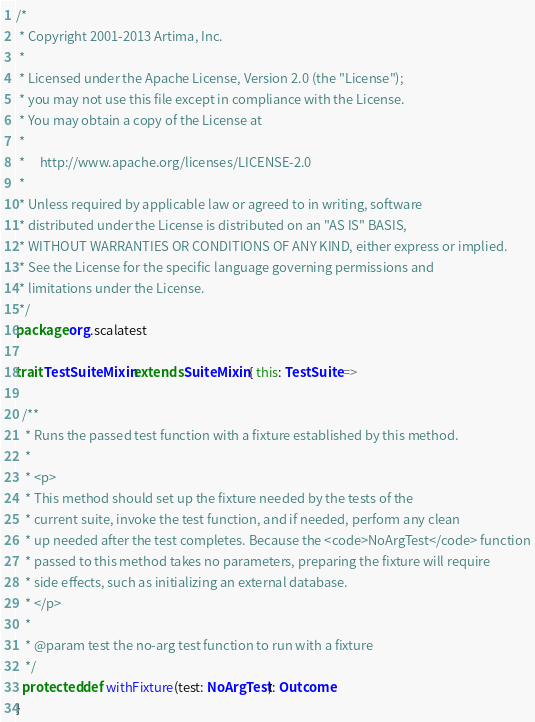<code> <loc_0><loc_0><loc_500><loc_500><_Scala_>/*
 * Copyright 2001-2013 Artima, Inc.
 *
 * Licensed under the Apache License, Version 2.0 (the "License");
 * you may not use this file except in compliance with the License.
 * You may obtain a copy of the License at
 *
 *     http://www.apache.org/licenses/LICENSE-2.0
 *
 * Unless required by applicable law or agreed to in writing, software
 * distributed under the License is distributed on an "AS IS" BASIS,
 * WITHOUT WARRANTIES OR CONDITIONS OF ANY KIND, either express or implied.
 * See the License for the specific language governing permissions and
 * limitations under the License.
 */
package org.scalatest

trait TestSuiteMixin extends SuiteMixin { this: TestSuite =>

  /**
   * Runs the passed test function with a fixture established by this method.
   *
   * <p>
   * This method should set up the fixture needed by the tests of the
   * current suite, invoke the test function, and if needed, perform any clean
   * up needed after the test completes. Because the <code>NoArgTest</code> function
   * passed to this method takes no parameters, preparing the fixture will require
   * side effects, such as initializing an external database.
   * </p>
   *
   * @param test the no-arg test function to run with a fixture
   */
  protected def withFixture(test: NoArgTest): Outcome
}

</code> 